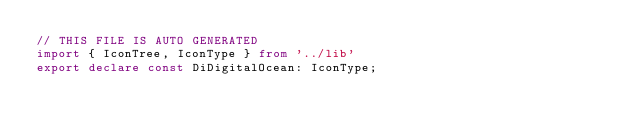Convert code to text. <code><loc_0><loc_0><loc_500><loc_500><_TypeScript_>// THIS FILE IS AUTO GENERATED
import { IconTree, IconType } from '../lib'
export declare const DiDigitalOcean: IconType;
</code> 